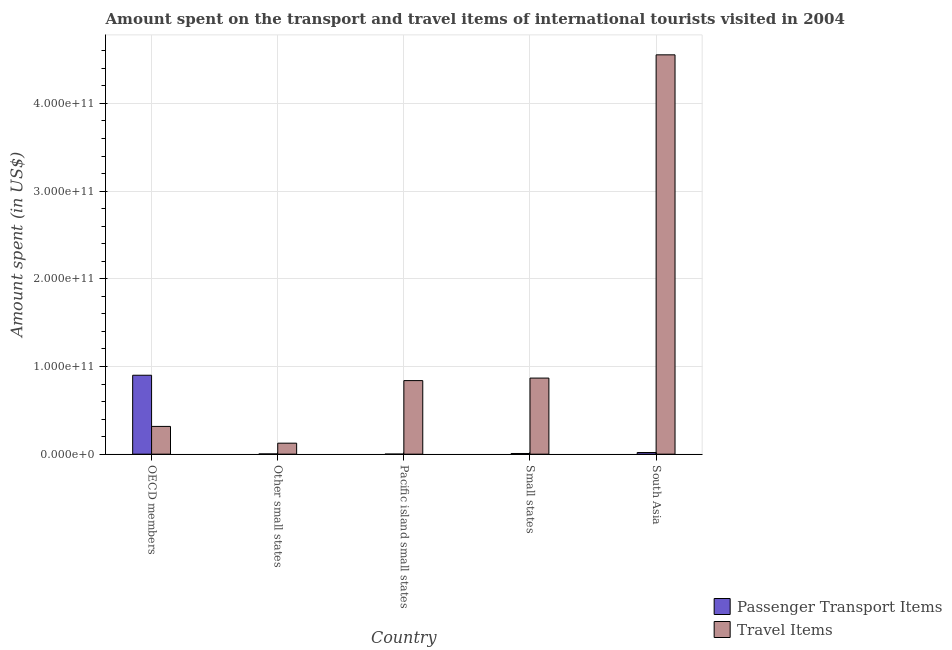How many different coloured bars are there?
Ensure brevity in your answer.  2. Are the number of bars per tick equal to the number of legend labels?
Offer a very short reply. Yes. Are the number of bars on each tick of the X-axis equal?
Make the answer very short. Yes. In how many cases, is the number of bars for a given country not equal to the number of legend labels?
Provide a succinct answer. 0. What is the amount spent on passenger transport items in Small states?
Your answer should be compact. 7.73e+08. Across all countries, what is the maximum amount spent in travel items?
Ensure brevity in your answer.  4.55e+11. Across all countries, what is the minimum amount spent on passenger transport items?
Ensure brevity in your answer.  7.11e+07. In which country was the amount spent on passenger transport items minimum?
Your response must be concise. Pacific island small states. What is the total amount spent in travel items in the graph?
Keep it short and to the point. 6.70e+11. What is the difference between the amount spent in travel items in Pacific island small states and that in Small states?
Make the answer very short. -2.88e+09. What is the difference between the amount spent on passenger transport items in South Asia and the amount spent in travel items in Other small states?
Offer a terse response. -1.06e+1. What is the average amount spent on passenger transport items per country?
Your answer should be compact. 1.86e+1. What is the difference between the amount spent in travel items and amount spent on passenger transport items in Small states?
Your answer should be compact. 8.60e+1. In how many countries, is the amount spent in travel items greater than 140000000000 US$?
Provide a short and direct response. 1. What is the ratio of the amount spent in travel items in OECD members to that in South Asia?
Your response must be concise. 0.07. What is the difference between the highest and the second highest amount spent on passenger transport items?
Provide a succinct answer. 8.81e+1. What is the difference between the highest and the lowest amount spent on passenger transport items?
Ensure brevity in your answer.  8.99e+1. In how many countries, is the amount spent in travel items greater than the average amount spent in travel items taken over all countries?
Give a very brief answer. 1. Is the sum of the amount spent in travel items in OECD members and South Asia greater than the maximum amount spent on passenger transport items across all countries?
Your response must be concise. Yes. What does the 2nd bar from the left in Small states represents?
Your answer should be compact. Travel Items. What does the 1st bar from the right in Small states represents?
Provide a short and direct response. Travel Items. What is the difference between two consecutive major ticks on the Y-axis?
Provide a succinct answer. 1.00e+11. Are the values on the major ticks of Y-axis written in scientific E-notation?
Give a very brief answer. Yes. Does the graph contain grids?
Keep it short and to the point. Yes. How many legend labels are there?
Your answer should be very brief. 2. What is the title of the graph?
Provide a short and direct response. Amount spent on the transport and travel items of international tourists visited in 2004. Does "Methane emissions" appear as one of the legend labels in the graph?
Your answer should be very brief. No. What is the label or title of the X-axis?
Provide a short and direct response. Country. What is the label or title of the Y-axis?
Provide a short and direct response. Amount spent (in US$). What is the Amount spent (in US$) in Passenger Transport Items in OECD members?
Your answer should be compact. 9.00e+1. What is the Amount spent (in US$) of Travel Items in OECD members?
Provide a succinct answer. 3.16e+1. What is the Amount spent (in US$) of Passenger Transport Items in Other small states?
Make the answer very short. 2.61e+08. What is the Amount spent (in US$) in Travel Items in Other small states?
Offer a terse response. 1.25e+1. What is the Amount spent (in US$) in Passenger Transport Items in Pacific island small states?
Make the answer very short. 7.11e+07. What is the Amount spent (in US$) in Travel Items in Pacific island small states?
Ensure brevity in your answer.  8.39e+1. What is the Amount spent (in US$) of Passenger Transport Items in Small states?
Your response must be concise. 7.73e+08. What is the Amount spent (in US$) in Travel Items in Small states?
Offer a terse response. 8.68e+1. What is the Amount spent (in US$) of Passenger Transport Items in South Asia?
Provide a short and direct response. 1.89e+09. What is the Amount spent (in US$) in Travel Items in South Asia?
Your answer should be compact. 4.55e+11. Across all countries, what is the maximum Amount spent (in US$) of Passenger Transport Items?
Give a very brief answer. 9.00e+1. Across all countries, what is the maximum Amount spent (in US$) of Travel Items?
Keep it short and to the point. 4.55e+11. Across all countries, what is the minimum Amount spent (in US$) of Passenger Transport Items?
Make the answer very short. 7.11e+07. Across all countries, what is the minimum Amount spent (in US$) of Travel Items?
Your answer should be very brief. 1.25e+1. What is the total Amount spent (in US$) of Passenger Transport Items in the graph?
Provide a short and direct response. 9.30e+1. What is the total Amount spent (in US$) of Travel Items in the graph?
Offer a terse response. 6.70e+11. What is the difference between the Amount spent (in US$) of Passenger Transport Items in OECD members and that in Other small states?
Your answer should be very brief. 8.97e+1. What is the difference between the Amount spent (in US$) of Travel Items in OECD members and that in Other small states?
Your answer should be very brief. 1.91e+1. What is the difference between the Amount spent (in US$) of Passenger Transport Items in OECD members and that in Pacific island small states?
Your response must be concise. 8.99e+1. What is the difference between the Amount spent (in US$) in Travel Items in OECD members and that in Pacific island small states?
Your answer should be very brief. -5.23e+1. What is the difference between the Amount spent (in US$) of Passenger Transport Items in OECD members and that in Small states?
Keep it short and to the point. 8.92e+1. What is the difference between the Amount spent (in US$) of Travel Items in OECD members and that in Small states?
Your answer should be compact. -5.51e+1. What is the difference between the Amount spent (in US$) of Passenger Transport Items in OECD members and that in South Asia?
Provide a succinct answer. 8.81e+1. What is the difference between the Amount spent (in US$) of Travel Items in OECD members and that in South Asia?
Your answer should be very brief. -4.24e+11. What is the difference between the Amount spent (in US$) in Passenger Transport Items in Other small states and that in Pacific island small states?
Make the answer very short. 1.89e+08. What is the difference between the Amount spent (in US$) in Travel Items in Other small states and that in Pacific island small states?
Give a very brief answer. -7.14e+1. What is the difference between the Amount spent (in US$) of Passenger Transport Items in Other small states and that in Small states?
Give a very brief answer. -5.12e+08. What is the difference between the Amount spent (in US$) in Travel Items in Other small states and that in Small states?
Your answer should be compact. -7.42e+1. What is the difference between the Amount spent (in US$) in Passenger Transport Items in Other small states and that in South Asia?
Ensure brevity in your answer.  -1.63e+09. What is the difference between the Amount spent (in US$) of Travel Items in Other small states and that in South Asia?
Provide a short and direct response. -4.43e+11. What is the difference between the Amount spent (in US$) in Passenger Transport Items in Pacific island small states and that in Small states?
Provide a short and direct response. -7.01e+08. What is the difference between the Amount spent (in US$) of Travel Items in Pacific island small states and that in Small states?
Your answer should be very brief. -2.88e+09. What is the difference between the Amount spent (in US$) in Passenger Transport Items in Pacific island small states and that in South Asia?
Your answer should be very brief. -1.82e+09. What is the difference between the Amount spent (in US$) of Travel Items in Pacific island small states and that in South Asia?
Make the answer very short. -3.72e+11. What is the difference between the Amount spent (in US$) of Passenger Transport Items in Small states and that in South Asia?
Your answer should be compact. -1.12e+09. What is the difference between the Amount spent (in US$) in Travel Items in Small states and that in South Asia?
Ensure brevity in your answer.  -3.69e+11. What is the difference between the Amount spent (in US$) of Passenger Transport Items in OECD members and the Amount spent (in US$) of Travel Items in Other small states?
Ensure brevity in your answer.  7.75e+1. What is the difference between the Amount spent (in US$) of Passenger Transport Items in OECD members and the Amount spent (in US$) of Travel Items in Pacific island small states?
Ensure brevity in your answer.  6.11e+09. What is the difference between the Amount spent (in US$) in Passenger Transport Items in OECD members and the Amount spent (in US$) in Travel Items in Small states?
Your answer should be compact. 3.23e+09. What is the difference between the Amount spent (in US$) of Passenger Transport Items in OECD members and the Amount spent (in US$) of Travel Items in South Asia?
Your answer should be compact. -3.65e+11. What is the difference between the Amount spent (in US$) in Passenger Transport Items in Other small states and the Amount spent (in US$) in Travel Items in Pacific island small states?
Offer a very short reply. -8.36e+1. What is the difference between the Amount spent (in US$) of Passenger Transport Items in Other small states and the Amount spent (in US$) of Travel Items in Small states?
Offer a terse response. -8.65e+1. What is the difference between the Amount spent (in US$) of Passenger Transport Items in Other small states and the Amount spent (in US$) of Travel Items in South Asia?
Give a very brief answer. -4.55e+11. What is the difference between the Amount spent (in US$) of Passenger Transport Items in Pacific island small states and the Amount spent (in US$) of Travel Items in Small states?
Offer a very short reply. -8.67e+1. What is the difference between the Amount spent (in US$) of Passenger Transport Items in Pacific island small states and the Amount spent (in US$) of Travel Items in South Asia?
Provide a short and direct response. -4.55e+11. What is the difference between the Amount spent (in US$) of Passenger Transport Items in Small states and the Amount spent (in US$) of Travel Items in South Asia?
Provide a succinct answer. -4.55e+11. What is the average Amount spent (in US$) in Passenger Transport Items per country?
Your answer should be compact. 1.86e+1. What is the average Amount spent (in US$) in Travel Items per country?
Offer a very short reply. 1.34e+11. What is the difference between the Amount spent (in US$) in Passenger Transport Items and Amount spent (in US$) in Travel Items in OECD members?
Provide a short and direct response. 5.84e+1. What is the difference between the Amount spent (in US$) in Passenger Transport Items and Amount spent (in US$) in Travel Items in Other small states?
Your answer should be compact. -1.23e+1. What is the difference between the Amount spent (in US$) of Passenger Transport Items and Amount spent (in US$) of Travel Items in Pacific island small states?
Your answer should be very brief. -8.38e+1. What is the difference between the Amount spent (in US$) in Passenger Transport Items and Amount spent (in US$) in Travel Items in Small states?
Your answer should be very brief. -8.60e+1. What is the difference between the Amount spent (in US$) of Passenger Transport Items and Amount spent (in US$) of Travel Items in South Asia?
Your answer should be compact. -4.54e+11. What is the ratio of the Amount spent (in US$) of Passenger Transport Items in OECD members to that in Other small states?
Make the answer very short. 345.42. What is the ratio of the Amount spent (in US$) in Travel Items in OECD members to that in Other small states?
Your answer should be very brief. 2.53. What is the ratio of the Amount spent (in US$) of Passenger Transport Items in OECD members to that in Pacific island small states?
Ensure brevity in your answer.  1265.69. What is the ratio of the Amount spent (in US$) of Travel Items in OECD members to that in Pacific island small states?
Ensure brevity in your answer.  0.38. What is the ratio of the Amount spent (in US$) in Passenger Transport Items in OECD members to that in Small states?
Offer a terse response. 116.5. What is the ratio of the Amount spent (in US$) of Travel Items in OECD members to that in Small states?
Provide a succinct answer. 0.36. What is the ratio of the Amount spent (in US$) of Passenger Transport Items in OECD members to that in South Asia?
Ensure brevity in your answer.  47.56. What is the ratio of the Amount spent (in US$) in Travel Items in OECD members to that in South Asia?
Keep it short and to the point. 0.07. What is the ratio of the Amount spent (in US$) of Passenger Transport Items in Other small states to that in Pacific island small states?
Provide a succinct answer. 3.66. What is the ratio of the Amount spent (in US$) in Travel Items in Other small states to that in Pacific island small states?
Offer a very short reply. 0.15. What is the ratio of the Amount spent (in US$) of Passenger Transport Items in Other small states to that in Small states?
Keep it short and to the point. 0.34. What is the ratio of the Amount spent (in US$) of Travel Items in Other small states to that in Small states?
Make the answer very short. 0.14. What is the ratio of the Amount spent (in US$) of Passenger Transport Items in Other small states to that in South Asia?
Your response must be concise. 0.14. What is the ratio of the Amount spent (in US$) of Travel Items in Other small states to that in South Asia?
Provide a succinct answer. 0.03. What is the ratio of the Amount spent (in US$) of Passenger Transport Items in Pacific island small states to that in Small states?
Give a very brief answer. 0.09. What is the ratio of the Amount spent (in US$) of Travel Items in Pacific island small states to that in Small states?
Your response must be concise. 0.97. What is the ratio of the Amount spent (in US$) of Passenger Transport Items in Pacific island small states to that in South Asia?
Your response must be concise. 0.04. What is the ratio of the Amount spent (in US$) of Travel Items in Pacific island small states to that in South Asia?
Provide a succinct answer. 0.18. What is the ratio of the Amount spent (in US$) of Passenger Transport Items in Small states to that in South Asia?
Your response must be concise. 0.41. What is the ratio of the Amount spent (in US$) in Travel Items in Small states to that in South Asia?
Your answer should be very brief. 0.19. What is the difference between the highest and the second highest Amount spent (in US$) of Passenger Transport Items?
Provide a succinct answer. 8.81e+1. What is the difference between the highest and the second highest Amount spent (in US$) of Travel Items?
Ensure brevity in your answer.  3.69e+11. What is the difference between the highest and the lowest Amount spent (in US$) of Passenger Transport Items?
Provide a short and direct response. 8.99e+1. What is the difference between the highest and the lowest Amount spent (in US$) in Travel Items?
Give a very brief answer. 4.43e+11. 